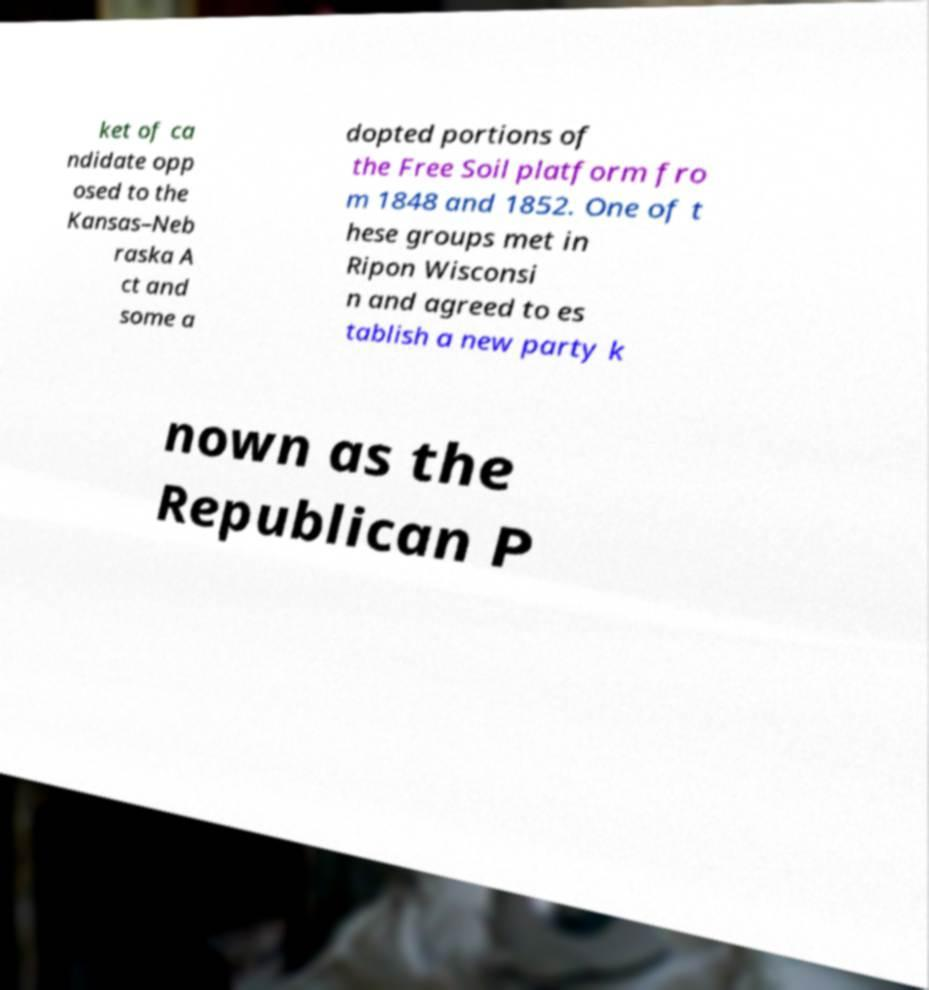I need the written content from this picture converted into text. Can you do that? ket of ca ndidate opp osed to the Kansas–Neb raska A ct and some a dopted portions of the Free Soil platform fro m 1848 and 1852. One of t hese groups met in Ripon Wisconsi n and agreed to es tablish a new party k nown as the Republican P 